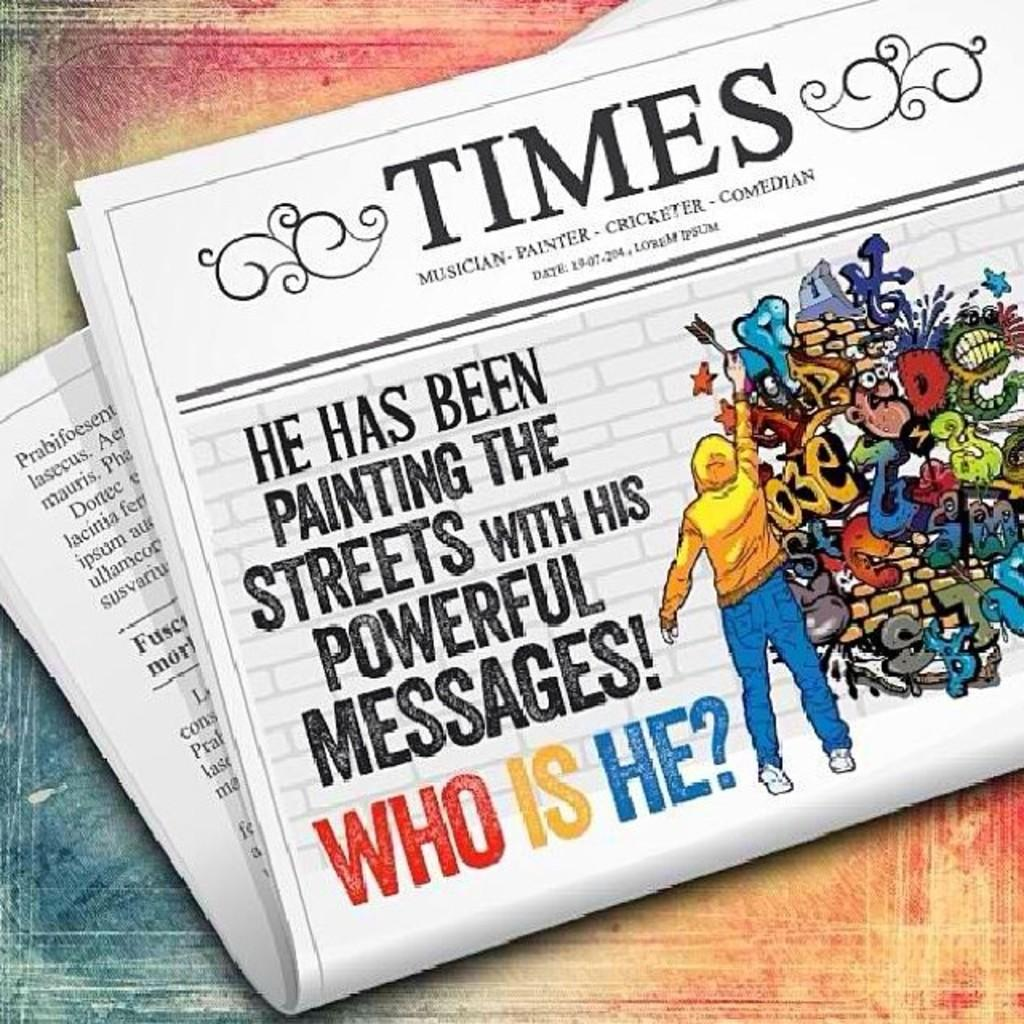<image>
Present a compact description of the photo's key features. A Times newspaper asks the question, "Who is he?" 